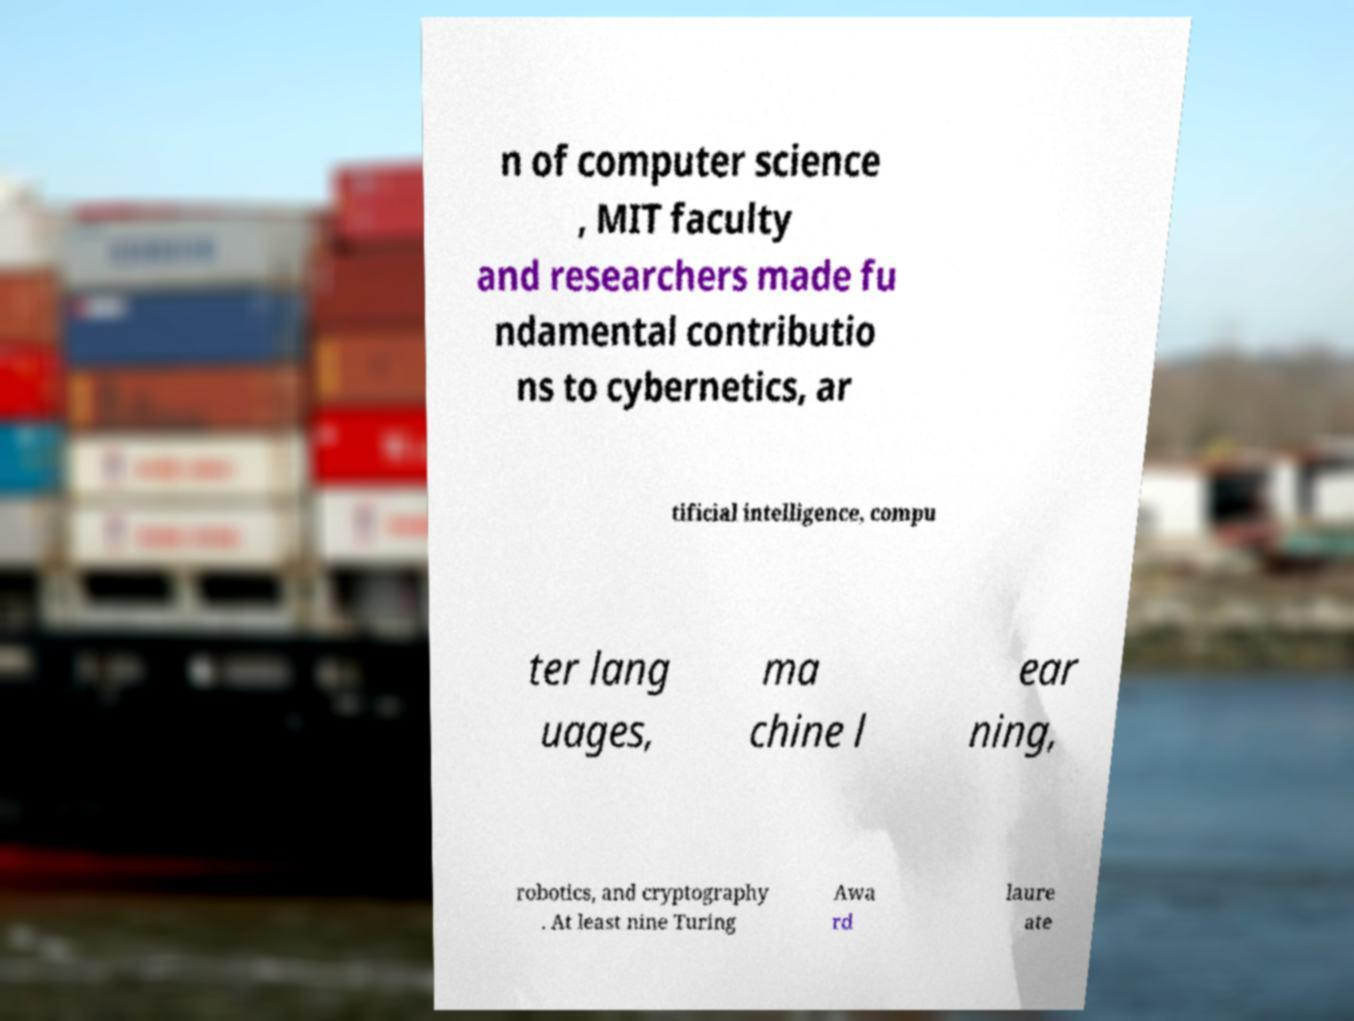There's text embedded in this image that I need extracted. Can you transcribe it verbatim? n of computer science , MIT faculty and researchers made fu ndamental contributio ns to cybernetics, ar tificial intelligence, compu ter lang uages, ma chine l ear ning, robotics, and cryptography . At least nine Turing Awa rd laure ate 